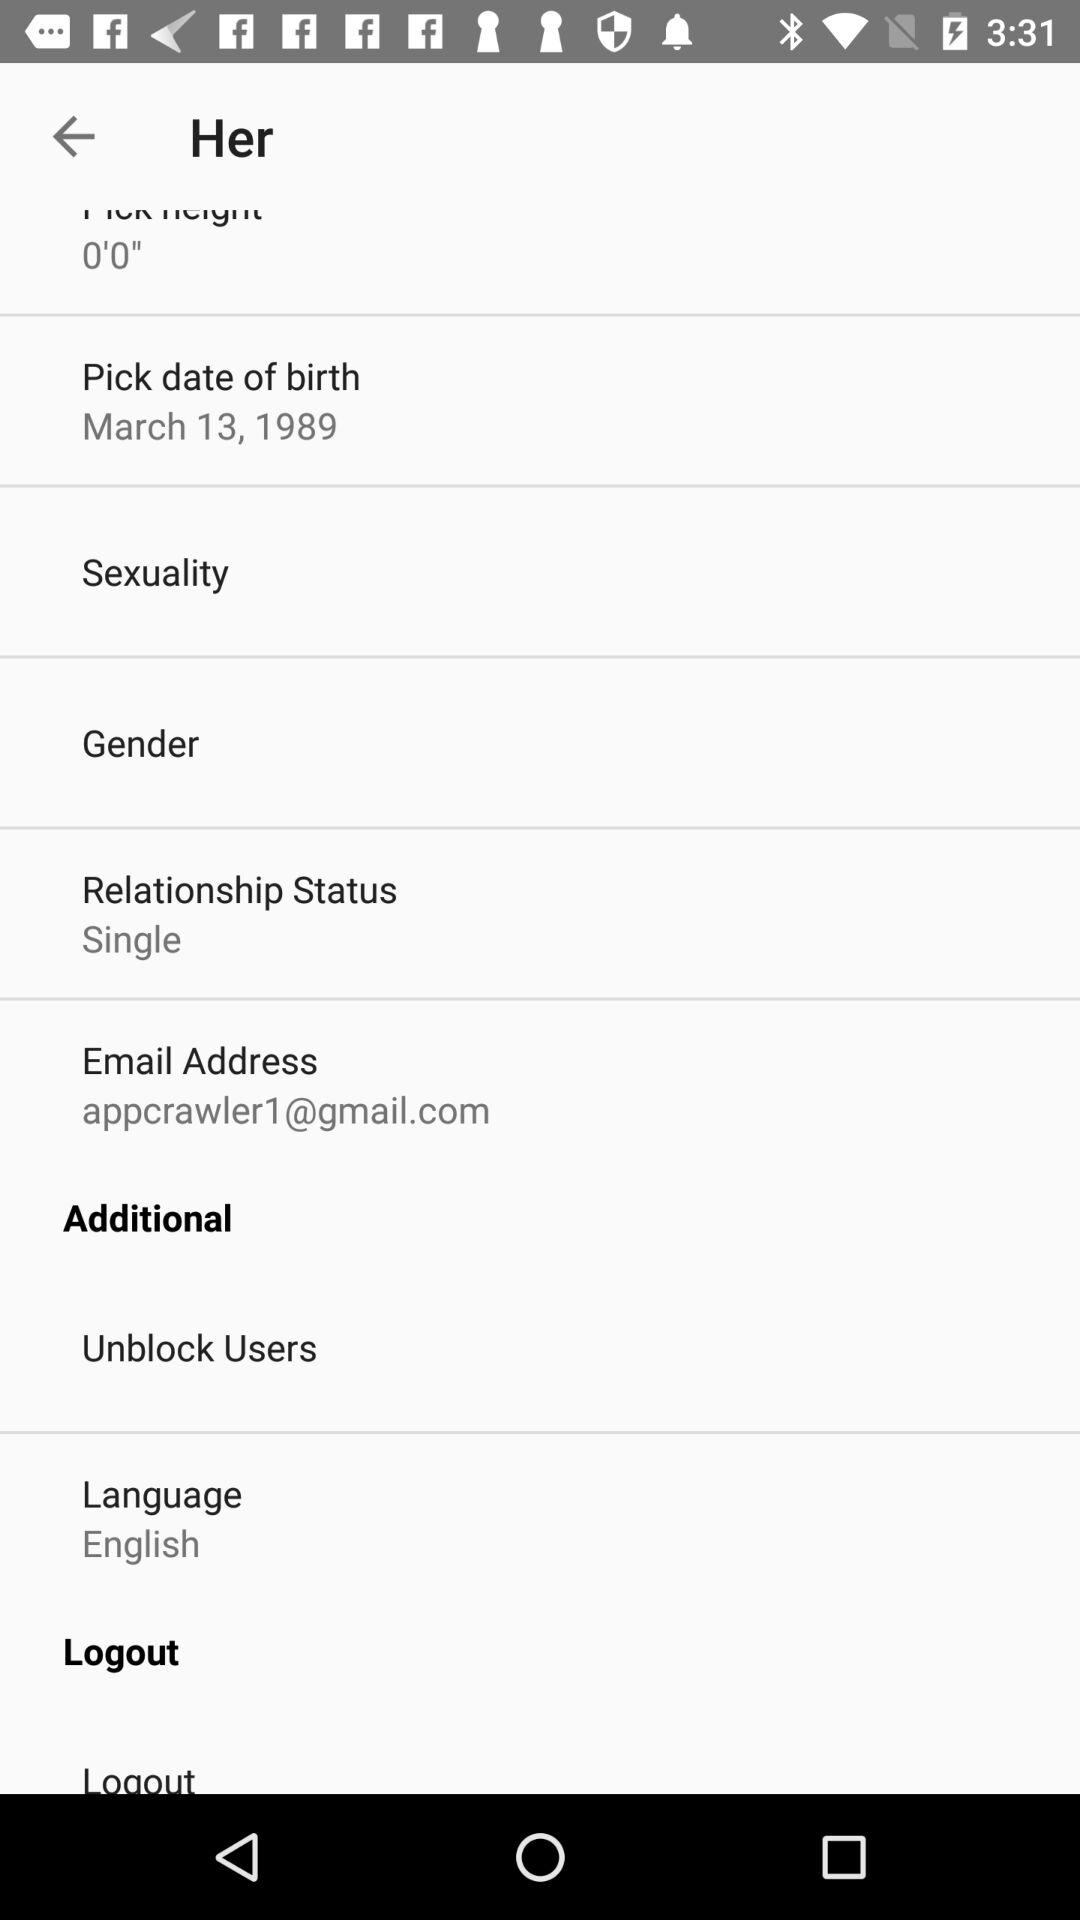What is the selected language? The selected language is English. 